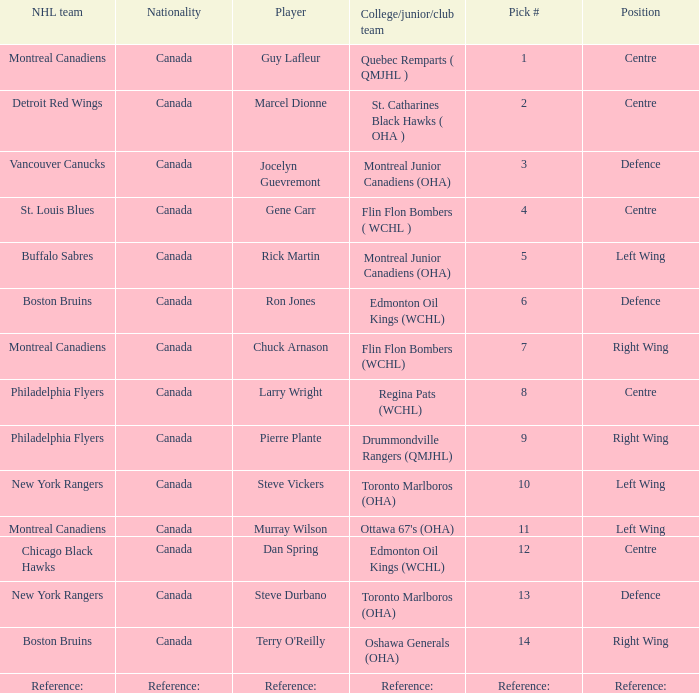Which College/junior/club team has a Pick # of 1? Quebec Remparts ( QMJHL ). 